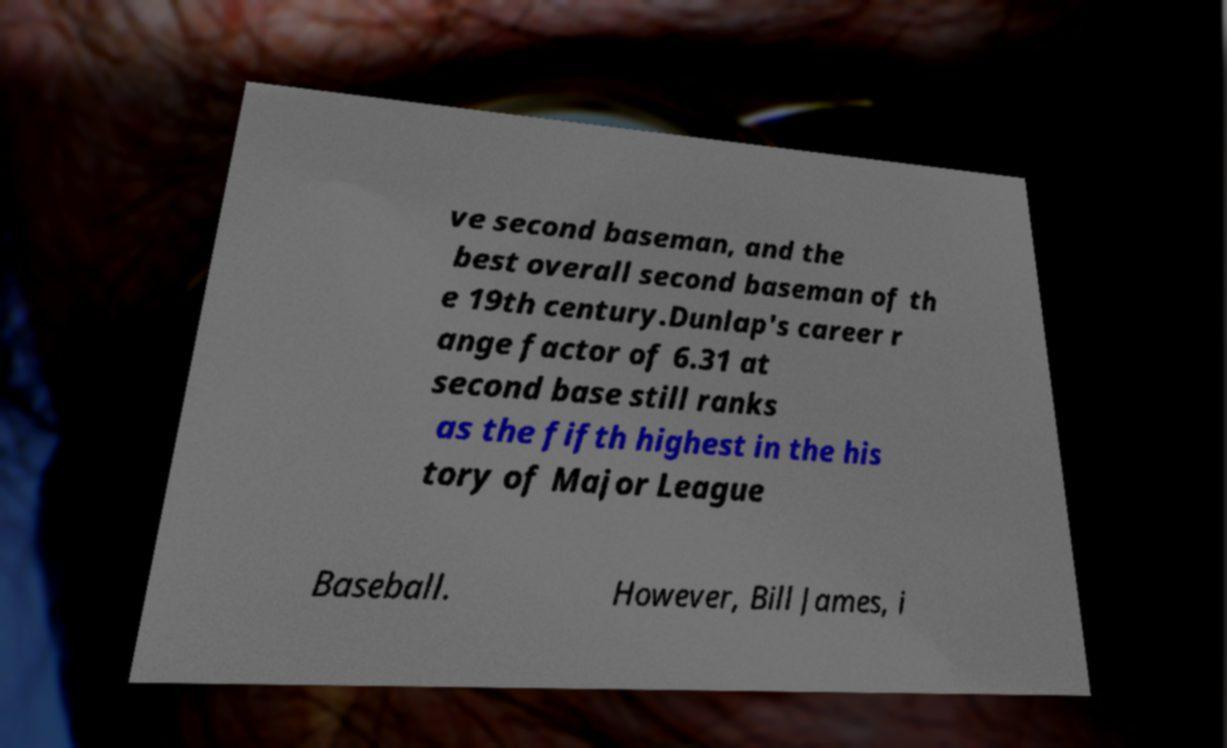Please identify and transcribe the text found in this image. ve second baseman, and the best overall second baseman of th e 19th century.Dunlap's career r ange factor of 6.31 at second base still ranks as the fifth highest in the his tory of Major League Baseball. However, Bill James, i 